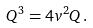<formula> <loc_0><loc_0><loc_500><loc_500>Q ^ { 3 } = 4 v ^ { 2 } Q \, .</formula> 